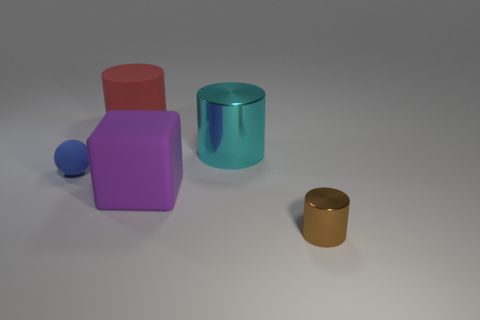The cylinder that is the same material as the blue thing is what color? red 